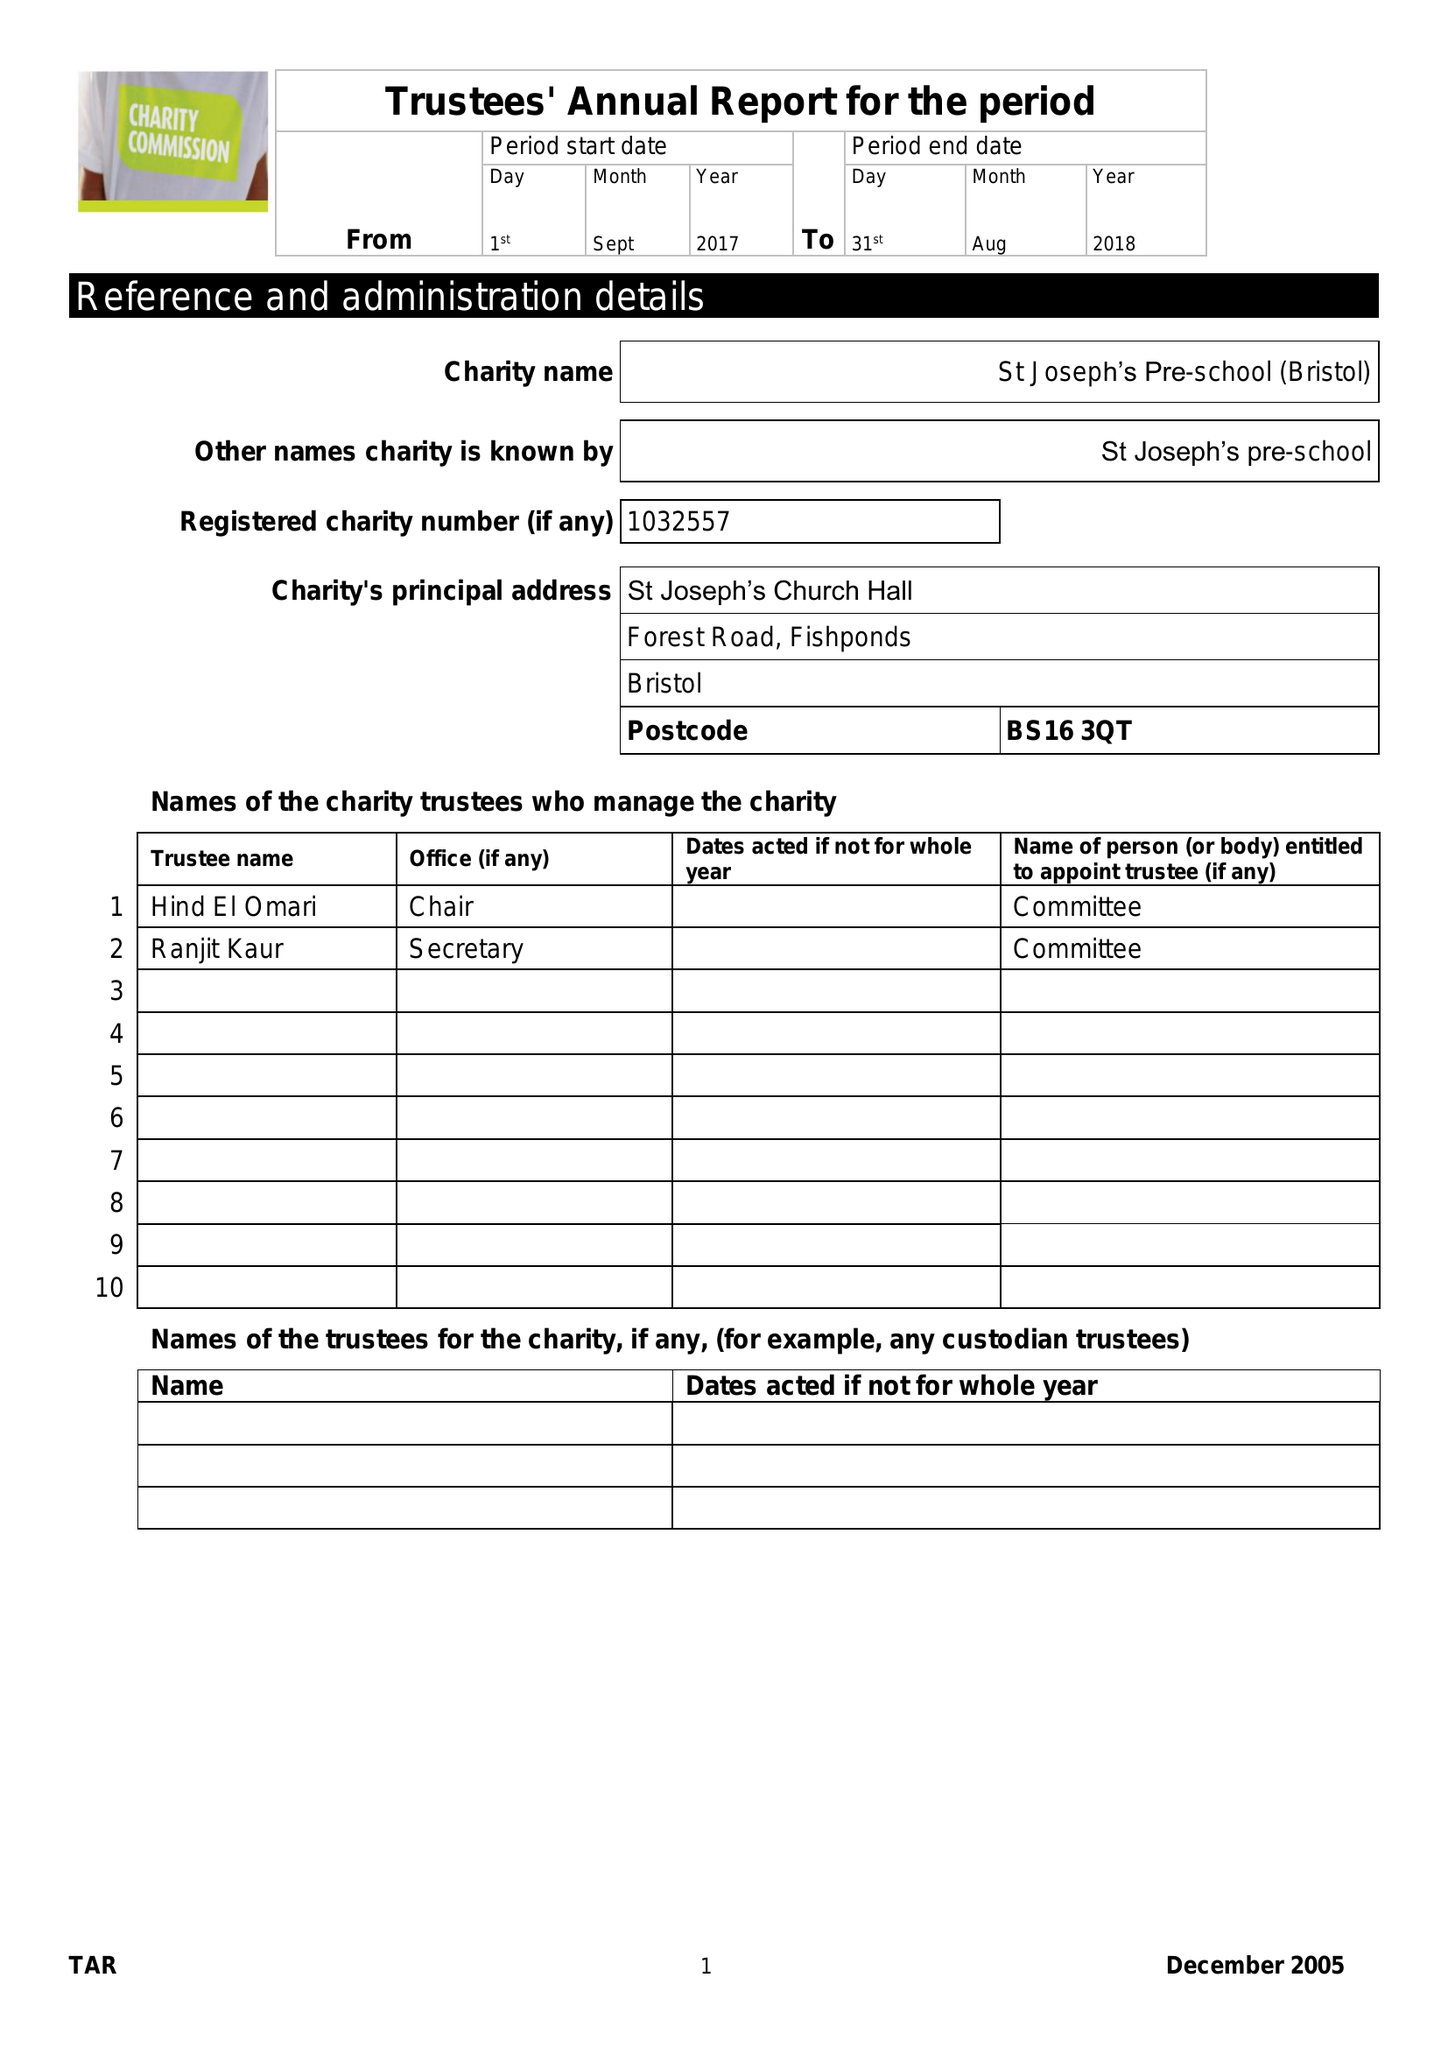What is the value for the report_date?
Answer the question using a single word or phrase. 2018-08-31 